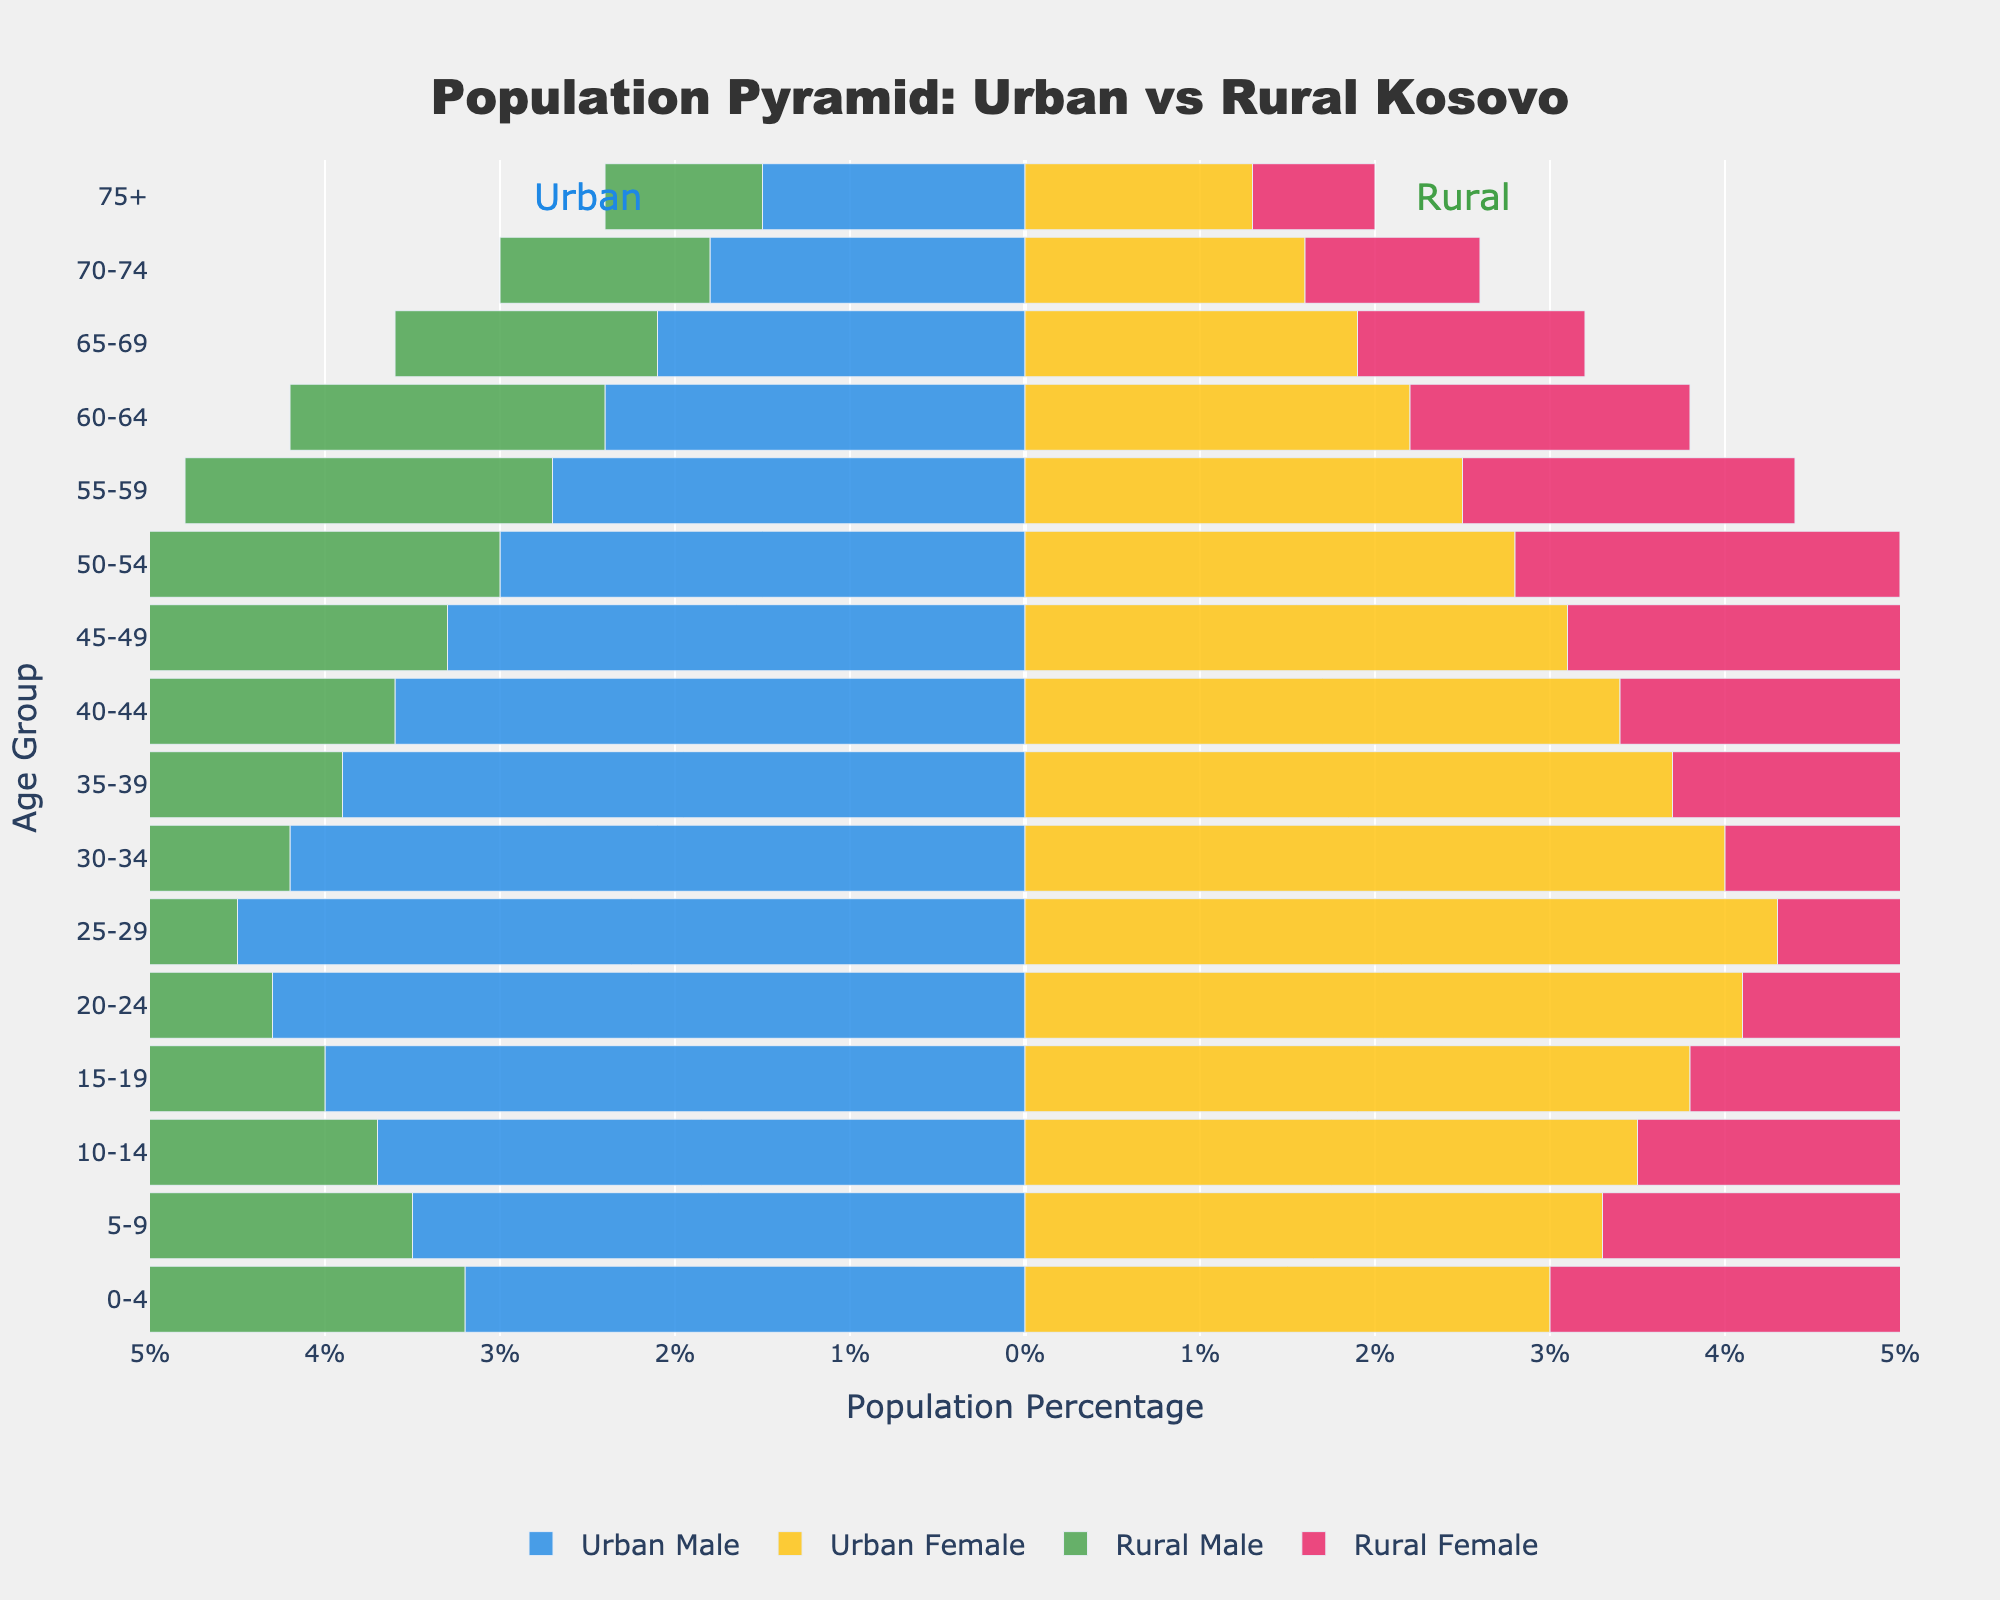What is the title of the figure? The title of the figure is displayed prominently at the top of the chart. It is typically where you would find the overall topic or subject of the visual data representation.
Answer: Population Pyramid: Urban vs Rural Kosovo How many age groups are represented in the figure? To find the number of age groups, you need to count the unique labels on the y-axis. These labels represent different age ranges.
Answer: 16 What color represents Urban Male in the figure? The color scheme for each category is provided in the legend of the figure. Urban Male can be identified by the color specified next to its label.
Answer: Blue Which age group has the highest percentage of Rural Females? To find this, locate the highest positive bar in the Rural Female section (pink bars) and check the corresponding age group on the y-axis.
Answer: 0-4 Compare the percentage of Urban Males and Rural Males in the 0-4 age group. For this, compare the lengths of the blue bar (Urban Male) and the green bar (Rural Male) for the 0-4 age group. Rural Male is longer.
Answer: Rural Male is higher In the 25-29 age group, which gender has a higher percentage in urban areas? Compare the lengths of the blue bar (Urban Male) and the yellow bar (Urban Female) for the 25-29 age group. Urban Female is longer.
Answer: Urban Female What is the percentage difference between Urban Females and Rural Females in the 70-74 age group? Locate the bars for Urban Female (yellow) and Rural Female (pink) in the 70-74 age group. Subtract the Rural Female percentage from the Urban Female percentage.
Answer: 0.6% Is the population of 20-24-year-olds higher in urban areas or rural areas? Compare the sum of Urban Male and Urban Female percentages in the 20-24 range with the sum of Rural Male and Rural Female percentages. Urban is higher.
Answer: Urban areas Which age group shows a decline in the rural population for both males and females compared to the previous age group? Examine the green and pink bars to identify the age group where both drop compared to the previous age group.
Answer: 30-34 Is there a significant difference in the population distribution between Urban and Rural areas for older age groups (70+)? Compare the lengths of the bars representing older age groups (70-74, 75+) between Urban and Rural populations. Urban areas have higher percentages.
Answer: Yes 